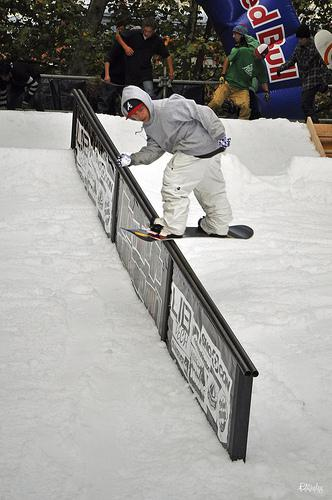Question: who is snowboarding?
Choices:
A. A young man.
B. A male.
C. A woman.
D. A child.
Answer with the letter. Answer: B Question: how did the man do that trick?
Choices:
A. Practice.
B. Jumped.
C. Twisted body.
D. Leap.
Answer with the letter. Answer: D Question: what advertisement is behind him?
Choices:
A. Bank of america.
B. Mercedes.
C. Diamond ring.
D. Red bull.
Answer with the letter. Answer: D Question: what season is it?
Choices:
A. During winter.
B. Summer.
C. Fall.
D. Spring.
Answer with the letter. Answer: A 